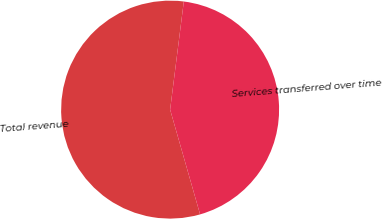<chart> <loc_0><loc_0><loc_500><loc_500><pie_chart><fcel>Total revenue<fcel>Services transferred over time<nl><fcel>56.44%<fcel>43.56%<nl></chart> 